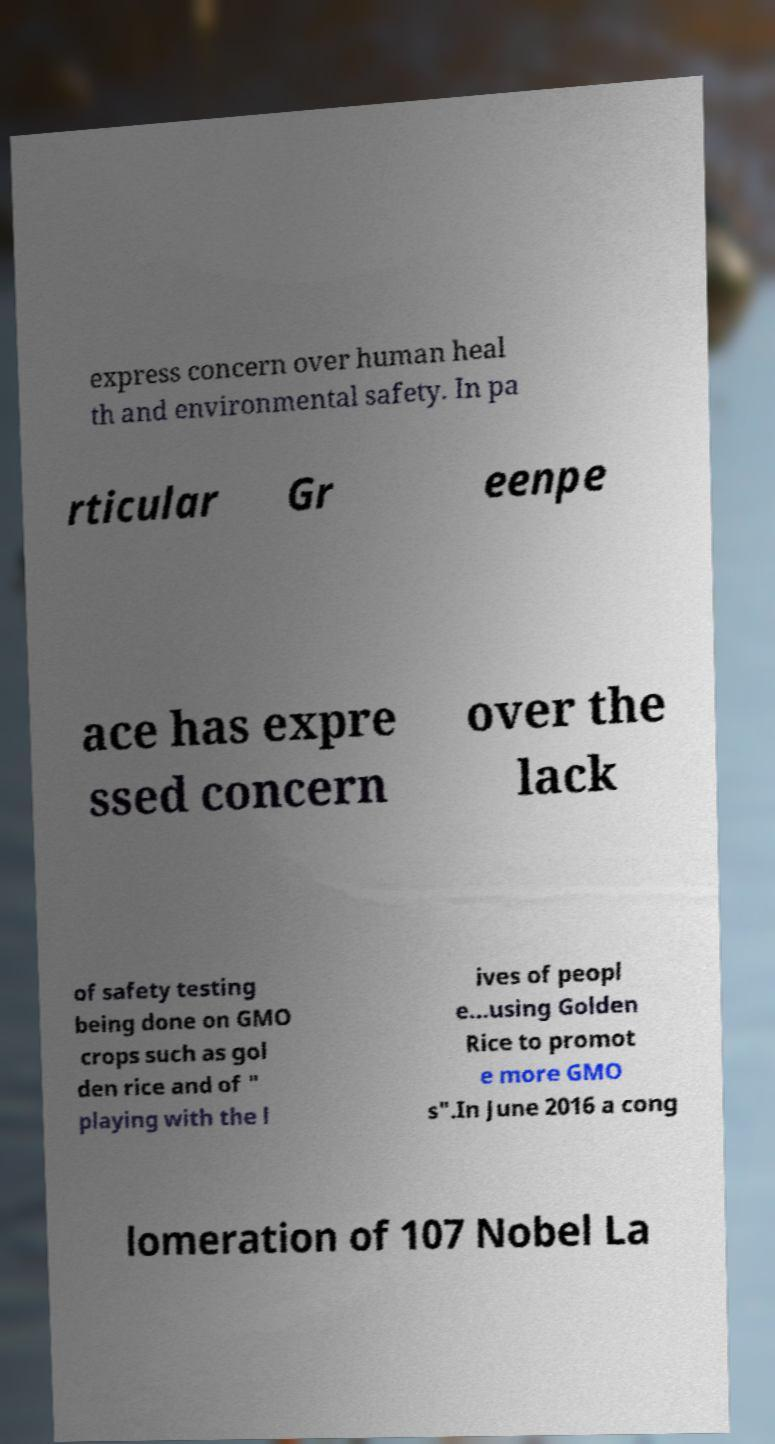Please read and relay the text visible in this image. What does it say? express concern over human heal th and environmental safety. In pa rticular Gr eenpe ace has expre ssed concern over the lack of safety testing being done on GMO crops such as gol den rice and of " playing with the l ives of peopl e...using Golden Rice to promot e more GMO s".In June 2016 a cong lomeration of 107 Nobel La 